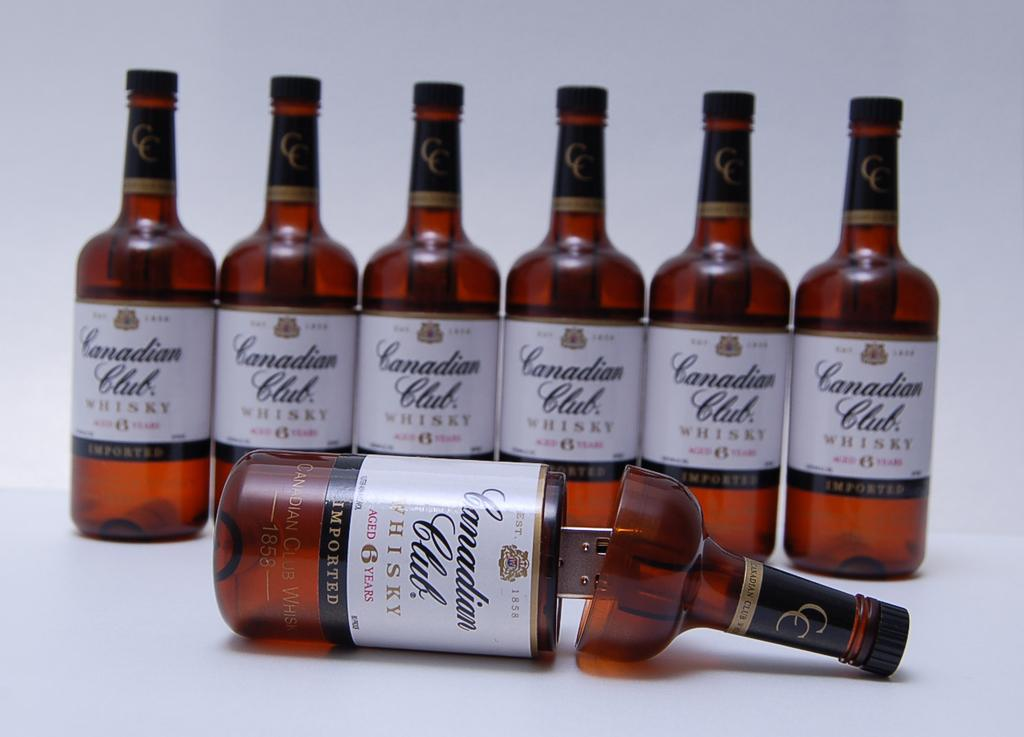<image>
Write a terse but informative summary of the picture. A row of bottles that open in half to be USB drives and say Canadian Club Whiskey. 